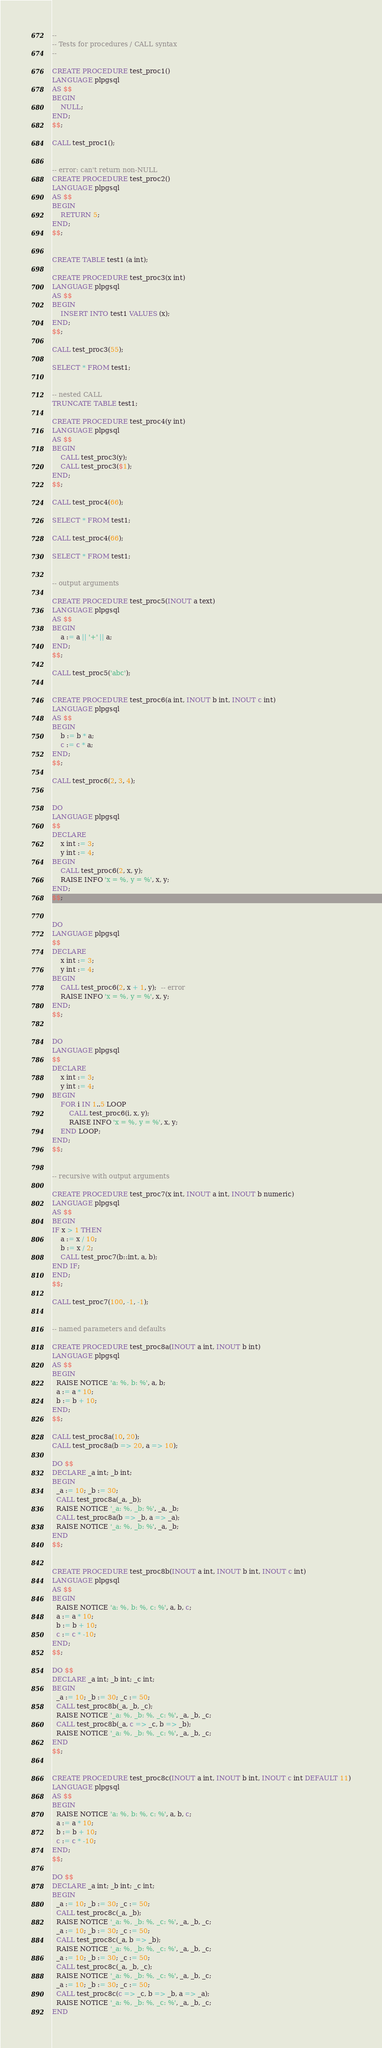Convert code to text. <code><loc_0><loc_0><loc_500><loc_500><_SQL_>--
-- Tests for procedures / CALL syntax
--

CREATE PROCEDURE test_proc1()
LANGUAGE plpgsql
AS $$
BEGIN
    NULL;
END;
$$;

CALL test_proc1();


-- error: can't return non-NULL
CREATE PROCEDURE test_proc2()
LANGUAGE plpgsql
AS $$
BEGIN
    RETURN 5;
END;
$$;


CREATE TABLE test1 (a int);

CREATE PROCEDURE test_proc3(x int)
LANGUAGE plpgsql
AS $$
BEGIN
    INSERT INTO test1 VALUES (x);
END;
$$;

CALL test_proc3(55);

SELECT * FROM test1;


-- nested CALL
TRUNCATE TABLE test1;

CREATE PROCEDURE test_proc4(y int)
LANGUAGE plpgsql
AS $$
BEGIN
    CALL test_proc3(y);
    CALL test_proc3($1);
END;
$$;

CALL test_proc4(66);

SELECT * FROM test1;

CALL test_proc4(66);

SELECT * FROM test1;


-- output arguments

CREATE PROCEDURE test_proc5(INOUT a text)
LANGUAGE plpgsql
AS $$
BEGIN
    a := a || '+' || a;
END;
$$;

CALL test_proc5('abc');


CREATE PROCEDURE test_proc6(a int, INOUT b int, INOUT c int)
LANGUAGE plpgsql
AS $$
BEGIN
    b := b * a;
    c := c * a;
END;
$$;

CALL test_proc6(2, 3, 4);


DO
LANGUAGE plpgsql
$$
DECLARE
    x int := 3;
    y int := 4;
BEGIN
    CALL test_proc6(2, x, y);
    RAISE INFO 'x = %, y = %', x, y;
END;
$$;


DO
LANGUAGE plpgsql
$$
DECLARE
    x int := 3;
    y int := 4;
BEGIN
    CALL test_proc6(2, x + 1, y);  -- error
    RAISE INFO 'x = %, y = %', x, y;
END;
$$;


DO
LANGUAGE plpgsql
$$
DECLARE
    x int := 3;
    y int := 4;
BEGIN
    FOR i IN 1..5 LOOP
        CALL test_proc6(i, x, y);
        RAISE INFO 'x = %, y = %', x, y;
    END LOOP;
END;
$$;


-- recursive with output arguments

CREATE PROCEDURE test_proc7(x int, INOUT a int, INOUT b numeric)
LANGUAGE plpgsql
AS $$
BEGIN
IF x > 1 THEN
    a := x / 10;
    b := x / 2;
    CALL test_proc7(b::int, a, b);
END IF;
END;
$$;

CALL test_proc7(100, -1, -1);


-- named parameters and defaults

CREATE PROCEDURE test_proc8a(INOUT a int, INOUT b int)
LANGUAGE plpgsql
AS $$
BEGIN
  RAISE NOTICE 'a: %, b: %', a, b;
  a := a * 10;
  b := b + 10;
END;
$$;

CALL test_proc8a(10, 20);
CALL test_proc8a(b => 20, a => 10);

DO $$
DECLARE _a int; _b int;
BEGIN
  _a := 10; _b := 30;
  CALL test_proc8a(_a, _b);
  RAISE NOTICE '_a: %, _b: %', _a, _b;
  CALL test_proc8a(b => _b, a => _a);
  RAISE NOTICE '_a: %, _b: %', _a, _b;
END
$$;


CREATE PROCEDURE test_proc8b(INOUT a int, INOUT b int, INOUT c int)
LANGUAGE plpgsql
AS $$
BEGIN
  RAISE NOTICE 'a: %, b: %, c: %', a, b, c;
  a := a * 10;
  b := b + 10;
  c := c * -10;
END;
$$;

DO $$
DECLARE _a int; _b int; _c int;
BEGIN
  _a := 10; _b := 30; _c := 50;
  CALL test_proc8b(_a, _b, _c);
  RAISE NOTICE '_a: %, _b: %, _c: %', _a, _b, _c;
  CALL test_proc8b(_a, c => _c, b => _b);
  RAISE NOTICE '_a: %, _b: %, _c: %', _a, _b, _c;
END
$$;


CREATE PROCEDURE test_proc8c(INOUT a int, INOUT b int, INOUT c int DEFAULT 11)
LANGUAGE plpgsql
AS $$
BEGIN
  RAISE NOTICE 'a: %, b: %, c: %', a, b, c;
  a := a * 10;
  b := b + 10;
  c := c * -10;
END;
$$;

DO $$
DECLARE _a int; _b int; _c int;
BEGIN
  _a := 10; _b := 30; _c := 50;
  CALL test_proc8c(_a, _b);
  RAISE NOTICE '_a: %, _b: %, _c: %', _a, _b, _c;
  _a := 10; _b := 30; _c := 50;
  CALL test_proc8c(_a, b => _b);
  RAISE NOTICE '_a: %, _b: %, _c: %', _a, _b, _c;
  _a := 10; _b := 30; _c := 50;
  CALL test_proc8c(_a, _b, _c);
  RAISE NOTICE '_a: %, _b: %, _c: %', _a, _b, _c;
  _a := 10; _b := 30; _c := 50;
  CALL test_proc8c(c => _c, b => _b, a => _a);
  RAISE NOTICE '_a: %, _b: %, _c: %', _a, _b, _c;
END</code> 